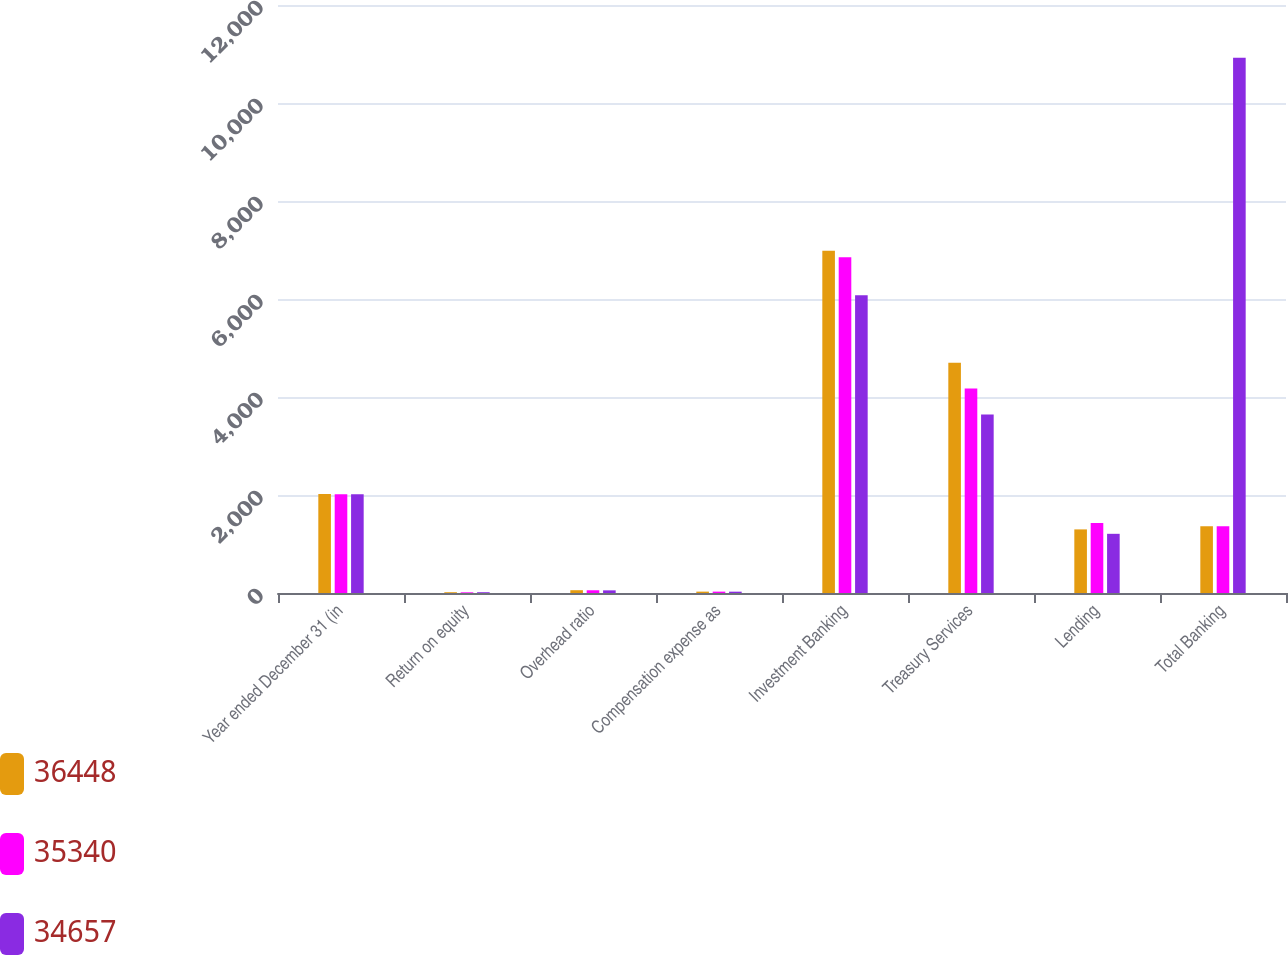Convert chart to OTSL. <chart><loc_0><loc_0><loc_500><loc_500><stacked_bar_chart><ecel><fcel>Year ended December 31 (in<fcel>Return on equity<fcel>Overhead ratio<fcel>Compensation expense as<fcel>Investment Banking<fcel>Treasury Services<fcel>Lending<fcel>Total Banking<nl><fcel>36448<fcel>2018<fcel>16<fcel>57<fcel>28<fcel>6987<fcel>4697<fcel>1298<fcel>1363.5<nl><fcel>35340<fcel>2017<fcel>14<fcel>56<fcel>28<fcel>6852<fcel>4172<fcel>1429<fcel>1363.5<nl><fcel>34657<fcel>2016<fcel>16<fcel>54<fcel>27<fcel>6074<fcel>3643<fcel>1208<fcel>10925<nl></chart> 